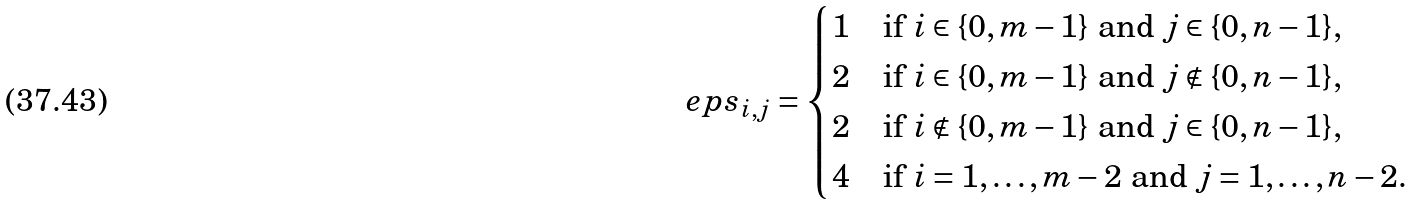Convert formula to latex. <formula><loc_0><loc_0><loc_500><loc_500>\ e p s _ { i , j } = \begin{cases} 1 & \text {if $i \in \{0,m-1\}$ and $j \in \{0,n-1\}$,} \\ 2 & \text {if $i \in \{0,m-1\}$ and $j \notin \{0,n-1\}$,} \\ 2 & \text {if $i \notin \{0,m-1\}$ and $j \in \{0,n-1\}$,} \\ 4 & \text {if $i =1,\dots,m-2$ and $j=1,\dots,n-2$.} \end{cases}</formula> 